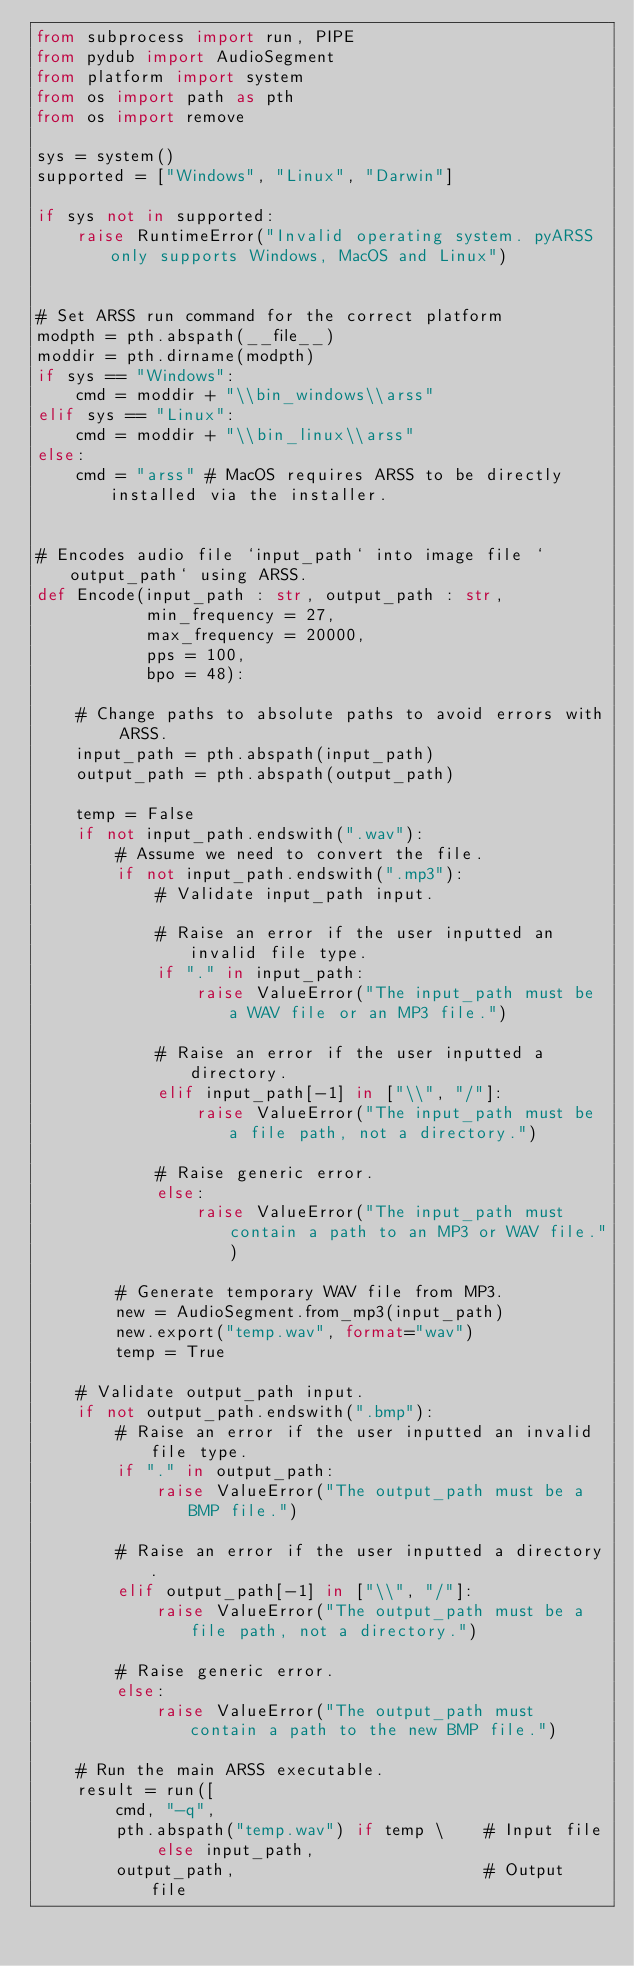<code> <loc_0><loc_0><loc_500><loc_500><_Python_>from subprocess import run, PIPE
from pydub import AudioSegment
from platform import system
from os import path as pth
from os import remove

sys = system()
supported = ["Windows", "Linux", "Darwin"]

if sys not in supported:
    raise RuntimeError("Invalid operating system. pyARSS only supports Windows, MacOS and Linux")


# Set ARSS run command for the correct platform
modpth = pth.abspath(__file__)
moddir = pth.dirname(modpth)
if sys == "Windows":
    cmd = moddir + "\\bin_windows\\arss"
elif sys == "Linux":
    cmd = moddir + "\\bin_linux\\arss"
else:
    cmd = "arss" # MacOS requires ARSS to be directly installed via the installer.


# Encodes audio file `input_path` into image file `output_path` using ARSS.
def Encode(input_path : str, output_path : str,
           min_frequency = 27,
           max_frequency = 20000,
           pps = 100,
           bpo = 48):
    
    # Change paths to absolute paths to avoid errors with ARSS.
    input_path = pth.abspath(input_path)
    output_path = pth.abspath(output_path)

    temp = False
    if not input_path.endswith(".wav"):
        # Assume we need to convert the file.
        if not input_path.endswith(".mp3"):
            # Validate input_path input.
            
            # Raise an error if the user inputted an invalid file type.
            if "." in input_path:
                raise ValueError("The input_path must be a WAV file or an MP3 file.")

            # Raise an error if the user inputted a directory.
            elif input_path[-1] in ["\\", "/"]:
                raise ValueError("The input_path must be a file path, not a directory.")

            # Raise generic error.
            else:
                raise ValueError("The input_path must contain a path to an MP3 or WAV file.")
        
        # Generate temporary WAV file from MP3.
        new = AudioSegment.from_mp3(input_path)
        new.export("temp.wav", format="wav")
        temp = True
    
    # Validate output_path input.
    if not output_path.endswith(".bmp"):
        # Raise an error if the user inputted an invalid file type.
        if "." in output_path:
            raise ValueError("The output_path must be a BMP file.")

        # Raise an error if the user inputted a directory.
        elif output_path[-1] in ["\\", "/"]:
            raise ValueError("The output_path must be a file path, not a directory.")

        # Raise generic error.
        else:
            raise ValueError("The output_path must contain a path to the new BMP file.")
    
    # Run the main ARSS executable.
    result = run([
        cmd, "-q",
        pth.abspath("temp.wav") if temp \    # Input file
            else input_path,                      
        output_path,                         # Output file</code> 